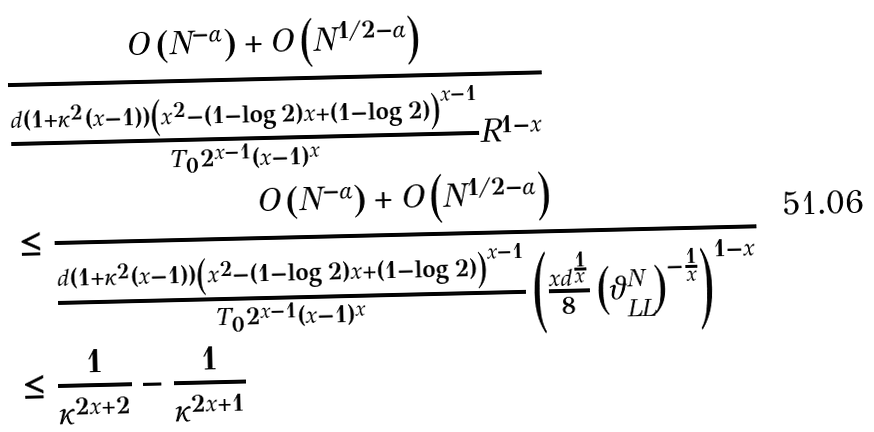Convert formula to latex. <formula><loc_0><loc_0><loc_500><loc_500>& \frac { O \left ( N ^ { - \alpha } \right ) + O \left ( N ^ { 1 / 2 - \alpha } \right ) } { \frac { d ( 1 + \kappa ^ { 2 } ( x - 1 ) ) \left ( x ^ { 2 } - ( 1 - \log 2 ) x + ( 1 - \log 2 ) \right ) ^ { x - 1 } } { T _ { 0 } 2 ^ { x - 1 } ( x - 1 ) ^ { x } } R ^ { 1 - x } } \\ & \leq \frac { O \left ( N ^ { - \alpha } \right ) + O \left ( N ^ { 1 / 2 - \alpha } \right ) } { \frac { d ( 1 + \kappa ^ { 2 } ( x - 1 ) ) \left ( x ^ { 2 } - ( 1 - \log 2 ) x + ( 1 - \log 2 ) \right ) ^ { x - 1 } } { T _ { 0 } 2 ^ { x - 1 } ( x - 1 ) ^ { x } } \left ( \frac { x d ^ { \frac { 1 } { x } } } { 8 } \left ( \vartheta _ { L L } ^ { N } \right ) ^ { - \frac { 1 } { x } } \right ) ^ { 1 - x } } \\ & \leq \frac { 1 } { \kappa ^ { 2 x + 2 } } - \frac { 1 } { \kappa ^ { 2 x + 1 } }</formula> 